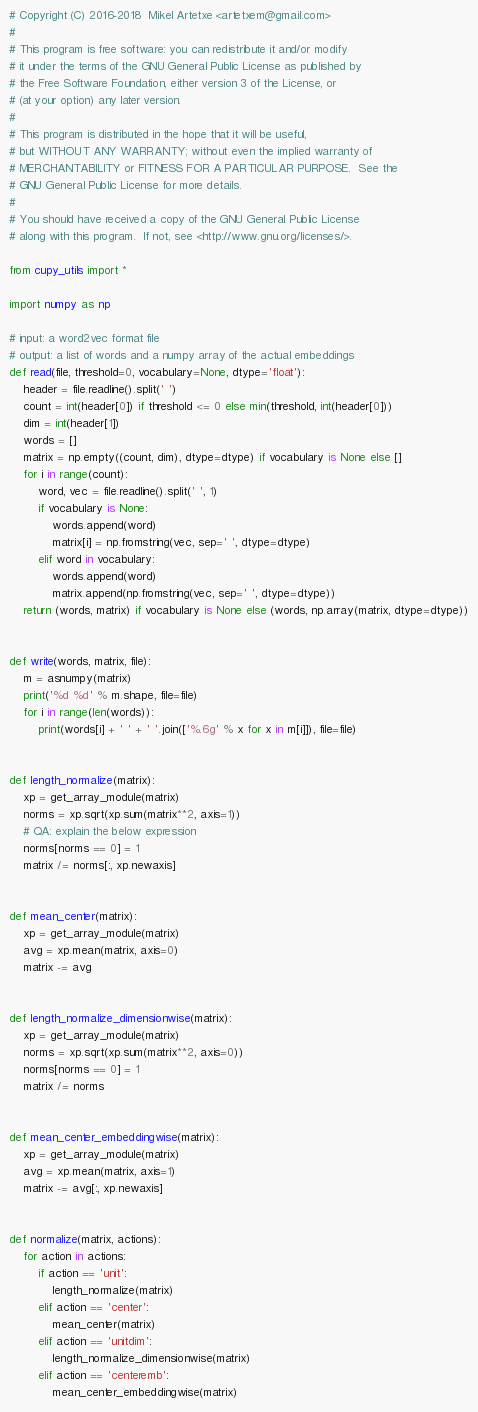Convert code to text. <code><loc_0><loc_0><loc_500><loc_500><_Python_># Copyright (C) 2016-2018  Mikel Artetxe <artetxem@gmail.com>
#
# This program is free software: you can redistribute it and/or modify
# it under the terms of the GNU General Public License as published by
# the Free Software Foundation, either version 3 of the License, or
# (at your option) any later version.
#
# This program is distributed in the hope that it will be useful,
# but WITHOUT ANY WARRANTY; without even the implied warranty of
# MERCHANTABILITY or FITNESS FOR A PARTICULAR PURPOSE.  See the
# GNU General Public License for more details.
#
# You should have received a copy of the GNU General Public License
# along with this program.  If not, see <http://www.gnu.org/licenses/>.

from cupy_utils import *

import numpy as np

# input: a word2vec format file
# output: a list of words and a numpy array of the actual embeddings
def read(file, threshold=0, vocabulary=None, dtype='float'):
    header = file.readline().split(' ')
    count = int(header[0]) if threshold <= 0 else min(threshold, int(header[0]))
    dim = int(header[1])
    words = []
    matrix = np.empty((count, dim), dtype=dtype) if vocabulary is None else []
    for i in range(count):
        word, vec = file.readline().split(' ', 1)
        if vocabulary is None:
            words.append(word)
            matrix[i] = np.fromstring(vec, sep=' ', dtype=dtype)
        elif word in vocabulary:
            words.append(word)
            matrix.append(np.fromstring(vec, sep=' ', dtype=dtype))
    return (words, matrix) if vocabulary is None else (words, np.array(matrix, dtype=dtype))


def write(words, matrix, file):
    m = asnumpy(matrix)
    print('%d %d' % m.shape, file=file)
    for i in range(len(words)):
        print(words[i] + ' ' + ' '.join(['%.6g' % x for x in m[i]]), file=file)


def length_normalize(matrix):
    xp = get_array_module(matrix)
    norms = xp.sqrt(xp.sum(matrix**2, axis=1))
    # QA: explain the below expression
    norms[norms == 0] = 1
    matrix /= norms[:, xp.newaxis]


def mean_center(matrix):
    xp = get_array_module(matrix)
    avg = xp.mean(matrix, axis=0)
    matrix -= avg


def length_normalize_dimensionwise(matrix):
    xp = get_array_module(matrix)
    norms = xp.sqrt(xp.sum(matrix**2, axis=0))
    norms[norms == 0] = 1
    matrix /= norms


def mean_center_embeddingwise(matrix):
    xp = get_array_module(matrix)
    avg = xp.mean(matrix, axis=1)
    matrix -= avg[:, xp.newaxis]


def normalize(matrix, actions):
    for action in actions:
        if action == 'unit':
            length_normalize(matrix)
        elif action == 'center':
            mean_center(matrix)
        elif action == 'unitdim':
            length_normalize_dimensionwise(matrix)
        elif action == 'centeremb':
            mean_center_embeddingwise(matrix)
</code> 